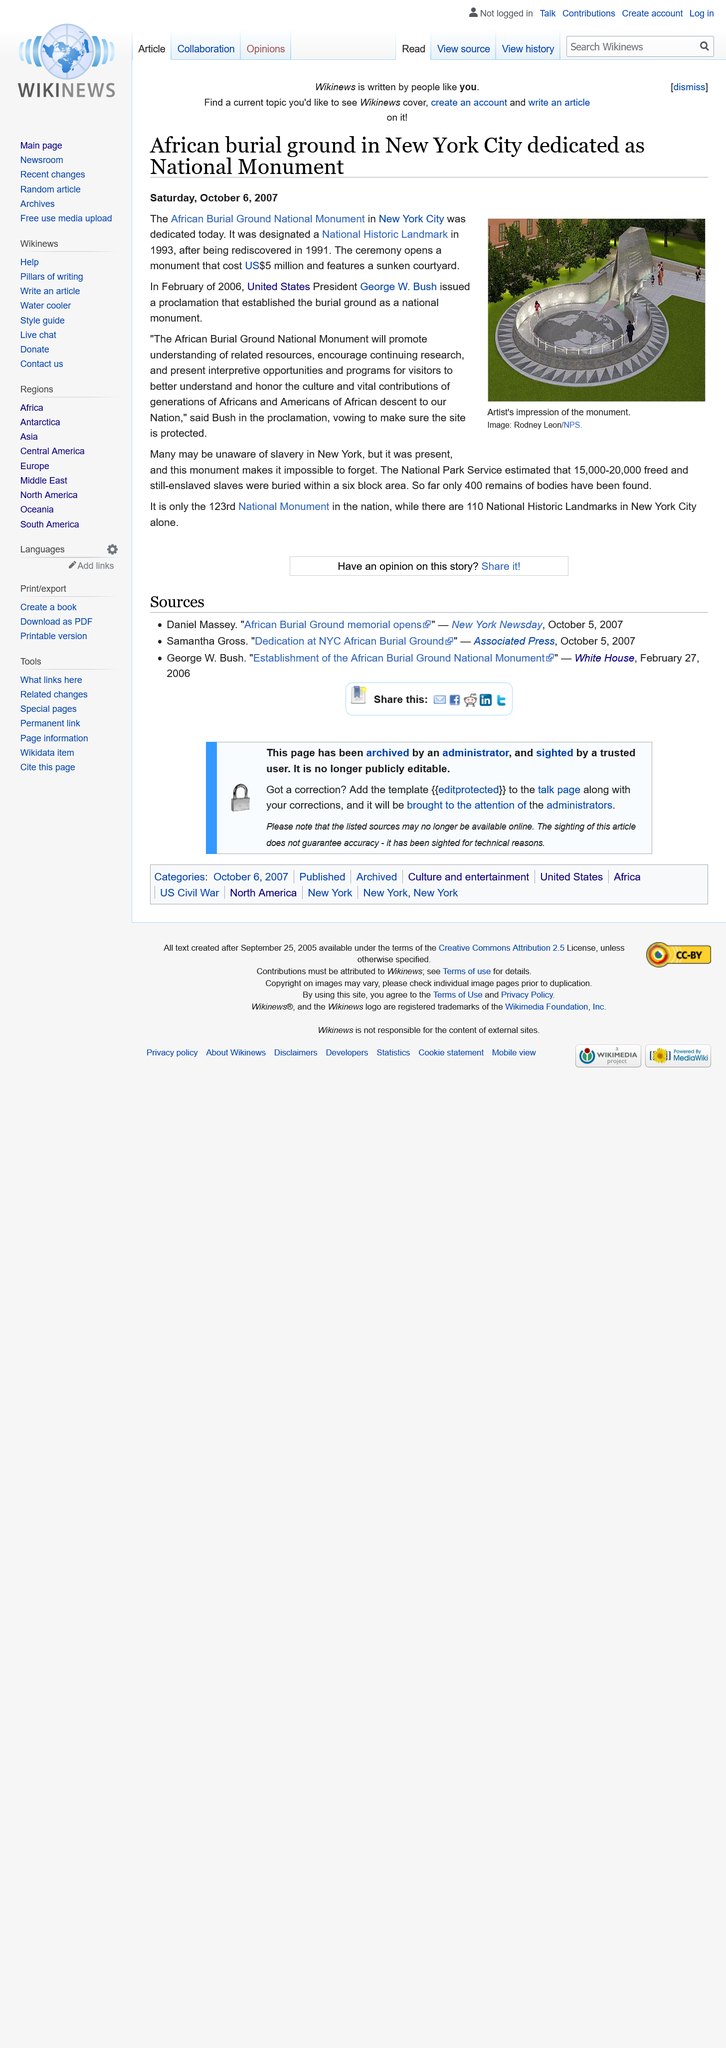Outline some significant characteristics in this image. The monument cost $5 million. The African Burial Ground National Monument was designated a National Historic Landmark in 1993. The image depicts an artist's representation of the African Burial Ground National Monument, which is a historic site in New York City that commemorates the remains of enslaved and free Africans who were interred there from the 17th to the 19th centuries. 